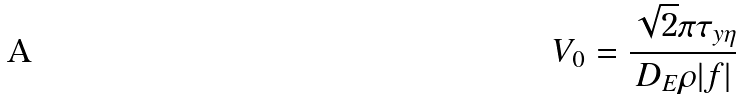<formula> <loc_0><loc_0><loc_500><loc_500>V _ { 0 } = \frac { \sqrt { 2 } \pi \tau _ { y \eta } } { D _ { E } \rho | f | }</formula> 